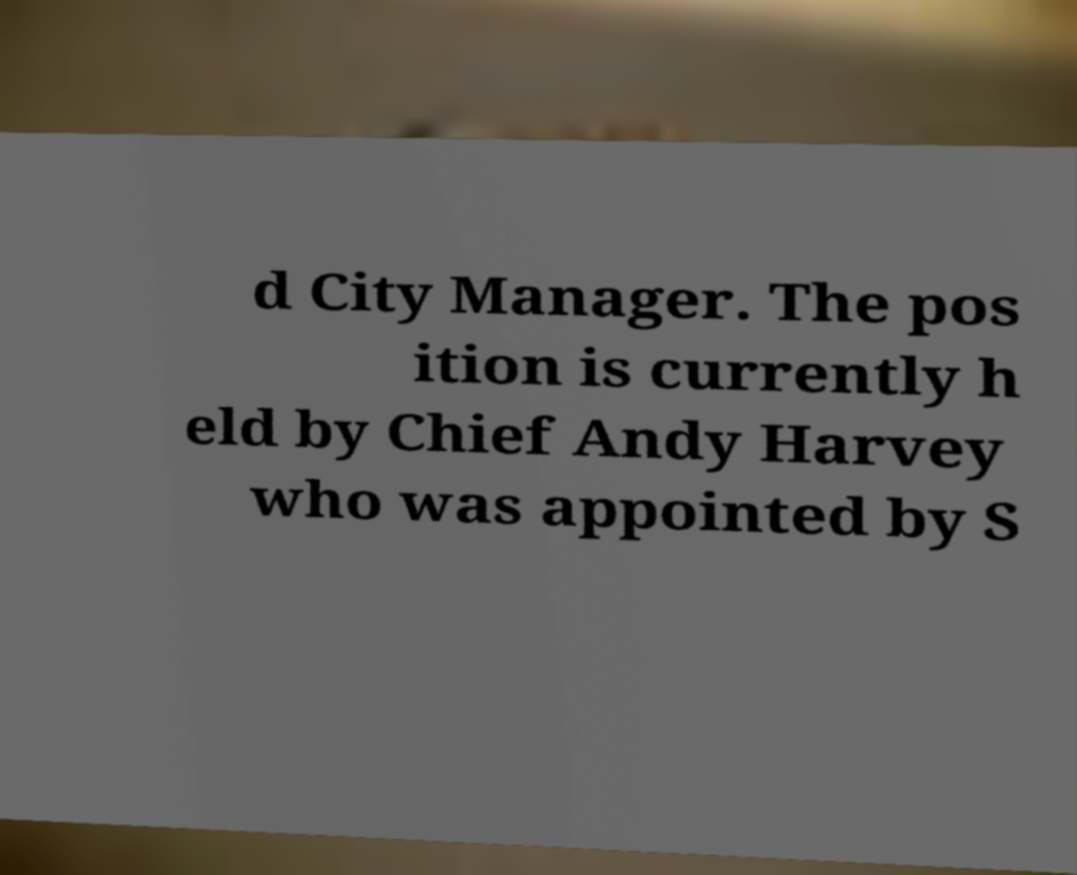Could you extract and type out the text from this image? d City Manager. The pos ition is currently h eld by Chief Andy Harvey who was appointed by S 